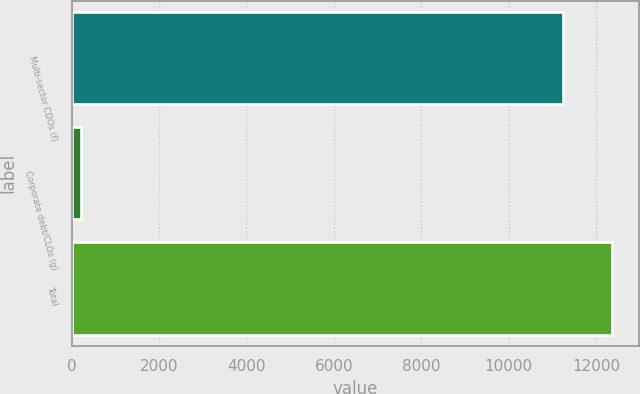Convert chart. <chart><loc_0><loc_0><loc_500><loc_500><bar_chart><fcel>Multi-sector CDOs (f)<fcel>Corporate debt/CLOs (g)<fcel>Total<nl><fcel>11246<fcel>226<fcel>12370.6<nl></chart> 